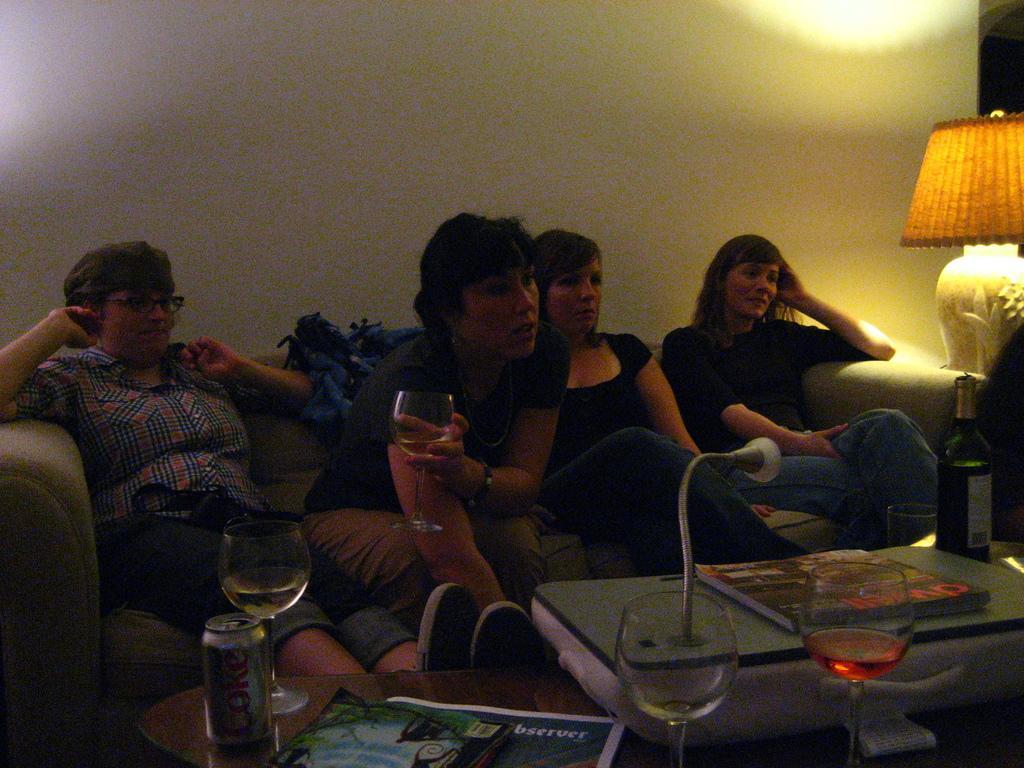Could you give a brief overview of what you see in this image? On the background we can see wall. We can see persons sitting on a sofa side by side. This is a lamp. On the table we can see tin, drinking glasses, paper and a book. 